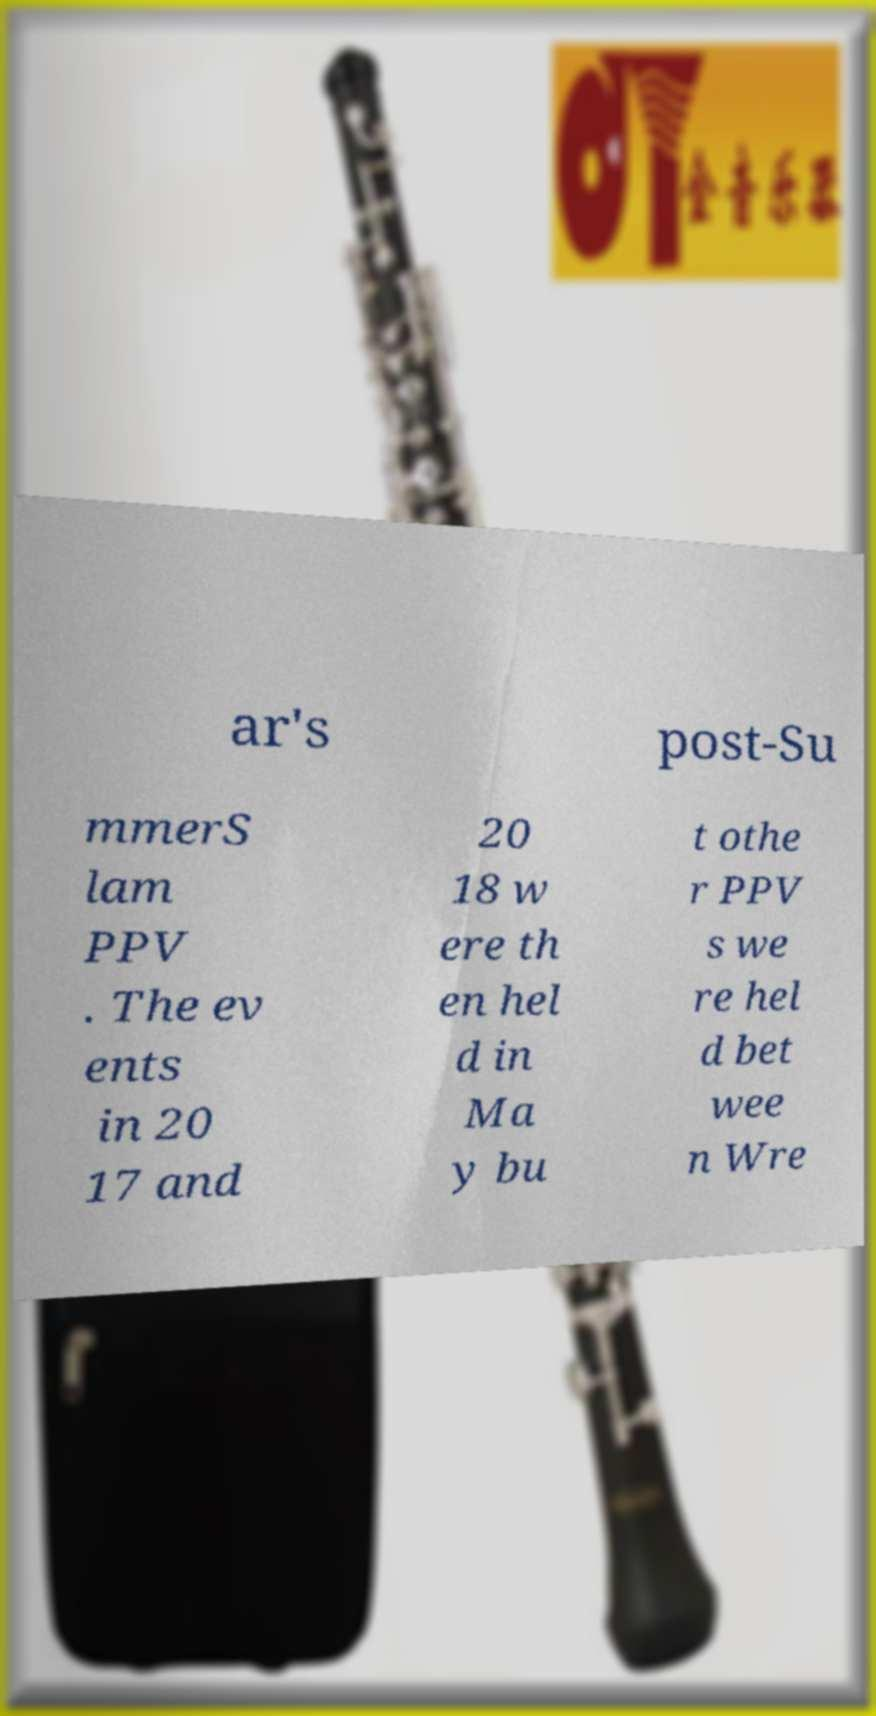Please identify and transcribe the text found in this image. ar's post-Su mmerS lam PPV . The ev ents in 20 17 and 20 18 w ere th en hel d in Ma y bu t othe r PPV s we re hel d bet wee n Wre 